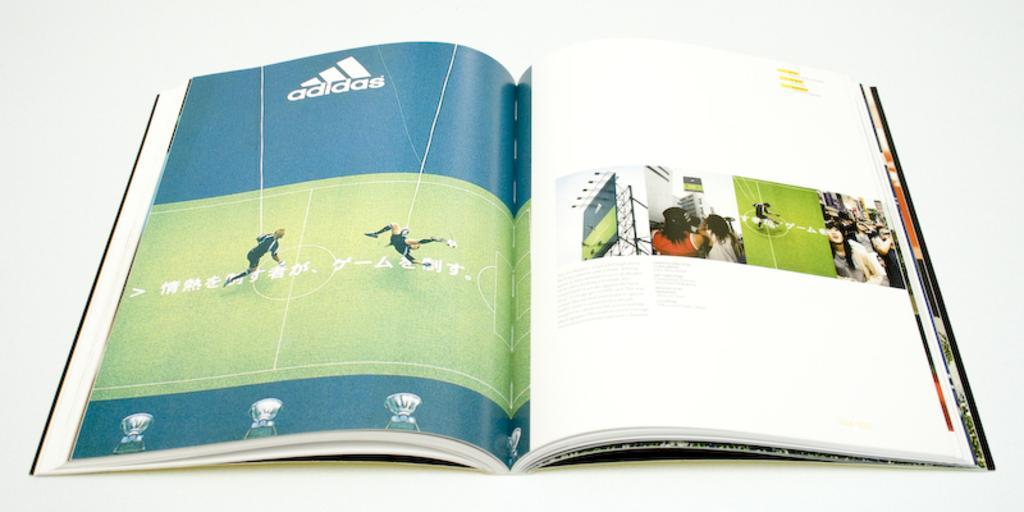Provide a one-sentence caption for the provided image. A magazine open to an advertisement from Adidas. 